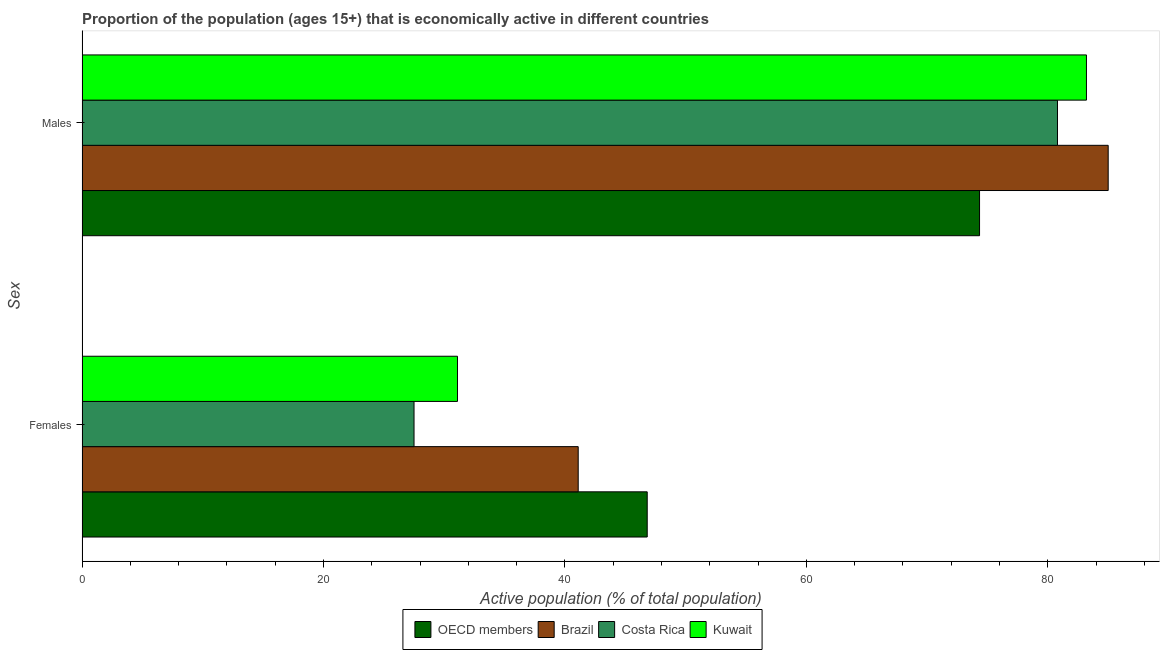Are the number of bars per tick equal to the number of legend labels?
Your answer should be very brief. Yes. How many bars are there on the 1st tick from the top?
Keep it short and to the point. 4. What is the label of the 2nd group of bars from the top?
Your response must be concise. Females. What is the percentage of economically active female population in Brazil?
Make the answer very short. 41.1. Across all countries, what is the minimum percentage of economically active male population?
Provide a short and direct response. 74.34. In which country was the percentage of economically active male population maximum?
Keep it short and to the point. Brazil. In which country was the percentage of economically active male population minimum?
Your answer should be compact. OECD members. What is the total percentage of economically active male population in the graph?
Provide a short and direct response. 323.34. What is the difference between the percentage of economically active male population in Kuwait and that in OECD members?
Your answer should be compact. 8.86. What is the difference between the percentage of economically active female population in Brazil and the percentage of economically active male population in Costa Rica?
Offer a very short reply. -39.7. What is the average percentage of economically active male population per country?
Your response must be concise. 80.84. What is the difference between the percentage of economically active female population and percentage of economically active male population in Costa Rica?
Provide a short and direct response. -53.3. What is the ratio of the percentage of economically active female population in OECD members to that in Brazil?
Offer a terse response. 1.14. What does the 2nd bar from the bottom in Males represents?
Offer a terse response. Brazil. Are all the bars in the graph horizontal?
Your answer should be very brief. Yes. How many countries are there in the graph?
Make the answer very short. 4. What is the difference between two consecutive major ticks on the X-axis?
Your answer should be very brief. 20. Are the values on the major ticks of X-axis written in scientific E-notation?
Provide a short and direct response. No. Does the graph contain grids?
Provide a succinct answer. No. Where does the legend appear in the graph?
Provide a short and direct response. Bottom center. What is the title of the graph?
Keep it short and to the point. Proportion of the population (ages 15+) that is economically active in different countries. What is the label or title of the X-axis?
Provide a succinct answer. Active population (% of total population). What is the label or title of the Y-axis?
Give a very brief answer. Sex. What is the Active population (% of total population) of OECD members in Females?
Your answer should be very brief. 46.82. What is the Active population (% of total population) in Brazil in Females?
Your answer should be compact. 41.1. What is the Active population (% of total population) in Costa Rica in Females?
Provide a succinct answer. 27.5. What is the Active population (% of total population) in Kuwait in Females?
Keep it short and to the point. 31.1. What is the Active population (% of total population) of OECD members in Males?
Make the answer very short. 74.34. What is the Active population (% of total population) in Brazil in Males?
Offer a terse response. 85. What is the Active population (% of total population) in Costa Rica in Males?
Your answer should be compact. 80.8. What is the Active population (% of total population) of Kuwait in Males?
Offer a very short reply. 83.2. Across all Sex, what is the maximum Active population (% of total population) of OECD members?
Your answer should be very brief. 74.34. Across all Sex, what is the maximum Active population (% of total population) in Costa Rica?
Your answer should be very brief. 80.8. Across all Sex, what is the maximum Active population (% of total population) of Kuwait?
Offer a very short reply. 83.2. Across all Sex, what is the minimum Active population (% of total population) of OECD members?
Give a very brief answer. 46.82. Across all Sex, what is the minimum Active population (% of total population) in Brazil?
Give a very brief answer. 41.1. Across all Sex, what is the minimum Active population (% of total population) in Costa Rica?
Ensure brevity in your answer.  27.5. Across all Sex, what is the minimum Active population (% of total population) in Kuwait?
Keep it short and to the point. 31.1. What is the total Active population (% of total population) of OECD members in the graph?
Your answer should be very brief. 121.16. What is the total Active population (% of total population) of Brazil in the graph?
Make the answer very short. 126.1. What is the total Active population (% of total population) in Costa Rica in the graph?
Offer a very short reply. 108.3. What is the total Active population (% of total population) of Kuwait in the graph?
Provide a short and direct response. 114.3. What is the difference between the Active population (% of total population) in OECD members in Females and that in Males?
Keep it short and to the point. -27.53. What is the difference between the Active population (% of total population) in Brazil in Females and that in Males?
Keep it short and to the point. -43.9. What is the difference between the Active population (% of total population) of Costa Rica in Females and that in Males?
Your answer should be very brief. -53.3. What is the difference between the Active population (% of total population) of Kuwait in Females and that in Males?
Your answer should be very brief. -52.1. What is the difference between the Active population (% of total population) in OECD members in Females and the Active population (% of total population) in Brazil in Males?
Your answer should be very brief. -38.18. What is the difference between the Active population (% of total population) in OECD members in Females and the Active population (% of total population) in Costa Rica in Males?
Your answer should be very brief. -33.98. What is the difference between the Active population (% of total population) in OECD members in Females and the Active population (% of total population) in Kuwait in Males?
Ensure brevity in your answer.  -36.38. What is the difference between the Active population (% of total population) of Brazil in Females and the Active population (% of total population) of Costa Rica in Males?
Provide a short and direct response. -39.7. What is the difference between the Active population (% of total population) of Brazil in Females and the Active population (% of total population) of Kuwait in Males?
Provide a short and direct response. -42.1. What is the difference between the Active population (% of total population) in Costa Rica in Females and the Active population (% of total population) in Kuwait in Males?
Keep it short and to the point. -55.7. What is the average Active population (% of total population) of OECD members per Sex?
Ensure brevity in your answer.  60.58. What is the average Active population (% of total population) of Brazil per Sex?
Offer a very short reply. 63.05. What is the average Active population (% of total population) in Costa Rica per Sex?
Give a very brief answer. 54.15. What is the average Active population (% of total population) of Kuwait per Sex?
Make the answer very short. 57.15. What is the difference between the Active population (% of total population) of OECD members and Active population (% of total population) of Brazil in Females?
Provide a short and direct response. 5.72. What is the difference between the Active population (% of total population) in OECD members and Active population (% of total population) in Costa Rica in Females?
Provide a short and direct response. 19.32. What is the difference between the Active population (% of total population) in OECD members and Active population (% of total population) in Kuwait in Females?
Your answer should be compact. 15.72. What is the difference between the Active population (% of total population) in Brazil and Active population (% of total population) in Costa Rica in Females?
Make the answer very short. 13.6. What is the difference between the Active population (% of total population) of OECD members and Active population (% of total population) of Brazil in Males?
Make the answer very short. -10.66. What is the difference between the Active population (% of total population) of OECD members and Active population (% of total population) of Costa Rica in Males?
Make the answer very short. -6.46. What is the difference between the Active population (% of total population) in OECD members and Active population (% of total population) in Kuwait in Males?
Make the answer very short. -8.86. What is the difference between the Active population (% of total population) in Brazil and Active population (% of total population) in Costa Rica in Males?
Ensure brevity in your answer.  4.2. What is the difference between the Active population (% of total population) of Costa Rica and Active population (% of total population) of Kuwait in Males?
Make the answer very short. -2.4. What is the ratio of the Active population (% of total population) in OECD members in Females to that in Males?
Provide a short and direct response. 0.63. What is the ratio of the Active population (% of total population) of Brazil in Females to that in Males?
Offer a terse response. 0.48. What is the ratio of the Active population (% of total population) of Costa Rica in Females to that in Males?
Make the answer very short. 0.34. What is the ratio of the Active population (% of total population) of Kuwait in Females to that in Males?
Your answer should be compact. 0.37. What is the difference between the highest and the second highest Active population (% of total population) in OECD members?
Offer a very short reply. 27.53. What is the difference between the highest and the second highest Active population (% of total population) of Brazil?
Offer a very short reply. 43.9. What is the difference between the highest and the second highest Active population (% of total population) in Costa Rica?
Provide a succinct answer. 53.3. What is the difference between the highest and the second highest Active population (% of total population) in Kuwait?
Make the answer very short. 52.1. What is the difference between the highest and the lowest Active population (% of total population) of OECD members?
Keep it short and to the point. 27.53. What is the difference between the highest and the lowest Active population (% of total population) of Brazil?
Provide a succinct answer. 43.9. What is the difference between the highest and the lowest Active population (% of total population) in Costa Rica?
Offer a very short reply. 53.3. What is the difference between the highest and the lowest Active population (% of total population) of Kuwait?
Provide a short and direct response. 52.1. 